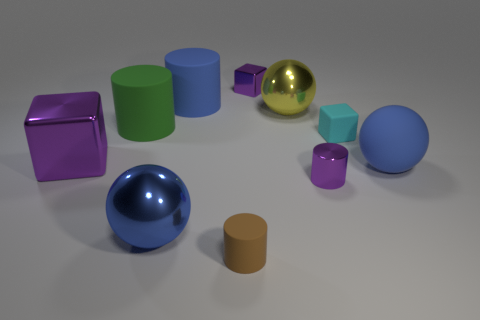Subtract all purple balls. How many purple cubes are left? 2 Subtract all yellow shiny balls. How many balls are left? 2 Subtract 2 cylinders. How many cylinders are left? 2 Subtract all blue cylinders. How many cylinders are left? 3 Subtract all cylinders. How many objects are left? 6 Subtract all large green cylinders. Subtract all blue balls. How many objects are left? 7 Add 6 big metallic blocks. How many big metallic blocks are left? 7 Add 6 small gray objects. How many small gray objects exist? 6 Subtract 0 green blocks. How many objects are left? 10 Subtract all gray cubes. Subtract all brown balls. How many cubes are left? 3 